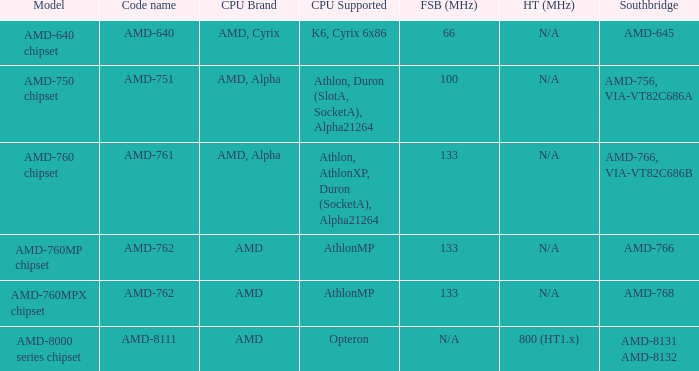What is the FSB / HT (MHz) when the Southbridge is amd-8131 amd-8132? 800 (HT1.x). 